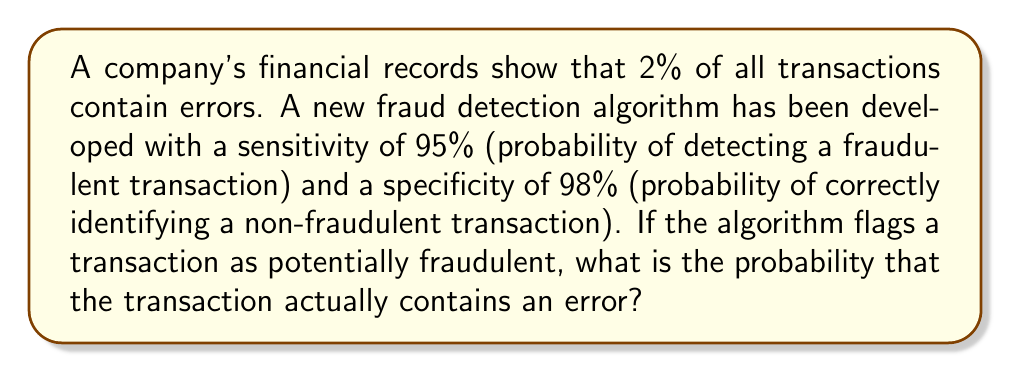Show me your answer to this math problem. Let's approach this problem using Bayes' Theorem. We'll define the following events:

E: Transaction contains an error
F: Transaction is flagged as fraudulent by the algorithm

Given:
P(E) = 0.02 (2% of transactions contain errors)
P(F|E) = 0.95 (sensitivity of the algorithm)
P(F|not E) = 1 - 0.98 = 0.02 (1 - specificity of the algorithm)

We want to find P(E|F), which is the probability that a transaction contains an error given that it was flagged as fraudulent.

Using Bayes' Theorem:

$$ P(E|F) = \frac{P(F|E) \cdot P(E)}{P(F)} $$

To find P(F), we use the law of total probability:

$$ P(F) = P(F|E) \cdot P(E) + P(F|not E) \cdot P(not E) $$

Calculating P(F):
$$ P(F) = 0.95 \cdot 0.02 + 0.02 \cdot 0.98 = 0.019 + 0.0196 = 0.0386 $$

Now we can apply Bayes' Theorem:

$$ P(E|F) = \frac{0.95 \cdot 0.02}{0.0386} = \frac{0.019}{0.0386} \approx 0.4922 $$

Therefore, the probability that a flagged transaction actually contains an error is approximately 0.4922 or 49.22%.
Answer: 0.4922 